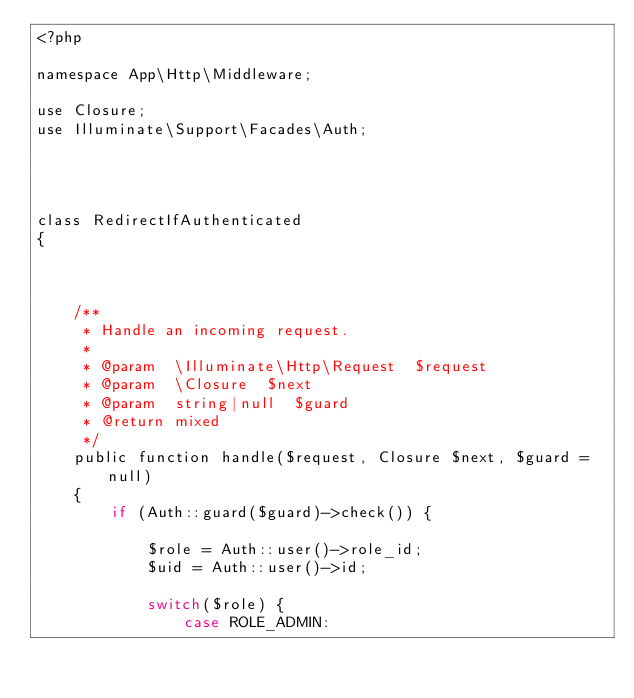<code> <loc_0><loc_0><loc_500><loc_500><_PHP_><?php

namespace App\Http\Middleware;

use Closure;
use Illuminate\Support\Facades\Auth;




class RedirectIfAuthenticated
{



    /**
     * Handle an incoming request.
     *
     * @param  \Illuminate\Http\Request  $request
     * @param  \Closure  $next
     * @param  string|null  $guard
     * @return mixed
     */
    public function handle($request, Closure $next, $guard = null)
    {
        if (Auth::guard($guard)->check()) {

            $role = Auth::user()->role_id;
            $uid = Auth::user()->id;

            switch($role) {
                case ROLE_ADMIN:</code> 